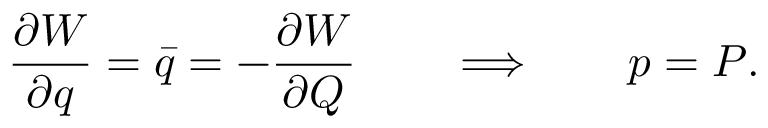Convert formula to latex. <formula><loc_0><loc_0><loc_500><loc_500>{ \frac { \partial W } { \partial q } } = \bar { q } = - { \frac { \partial W } { \partial Q } } \quad \Longrightarrow \quad p = P .</formula> 